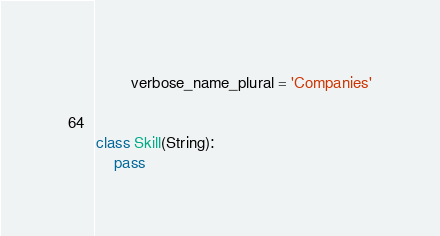<code> <loc_0><loc_0><loc_500><loc_500><_Python_>        verbose_name_plural = 'Companies'


class Skill(String):
    pass
</code> 